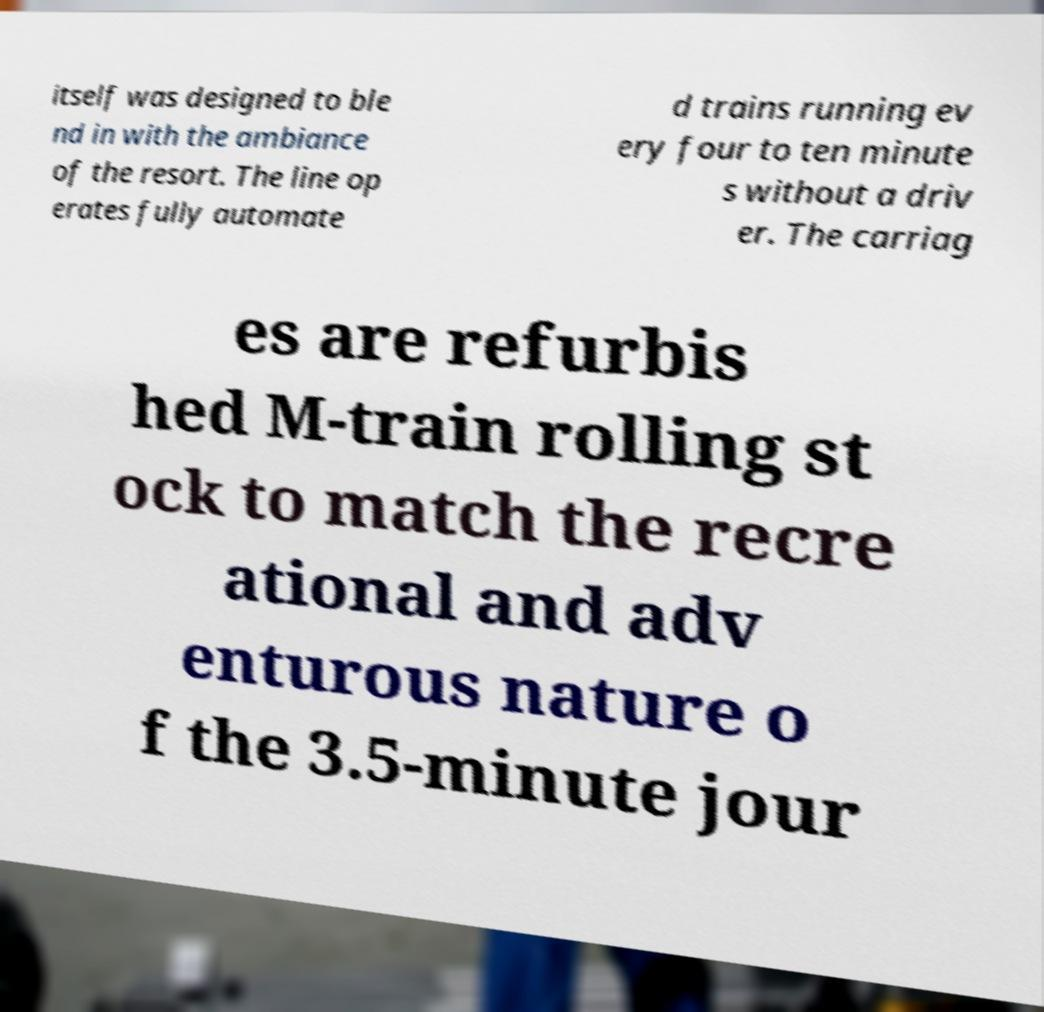For documentation purposes, I need the text within this image transcribed. Could you provide that? itself was designed to ble nd in with the ambiance of the resort. The line op erates fully automate d trains running ev ery four to ten minute s without a driv er. The carriag es are refurbis hed M-train rolling st ock to match the recre ational and adv enturous nature o f the 3.5-minute jour 